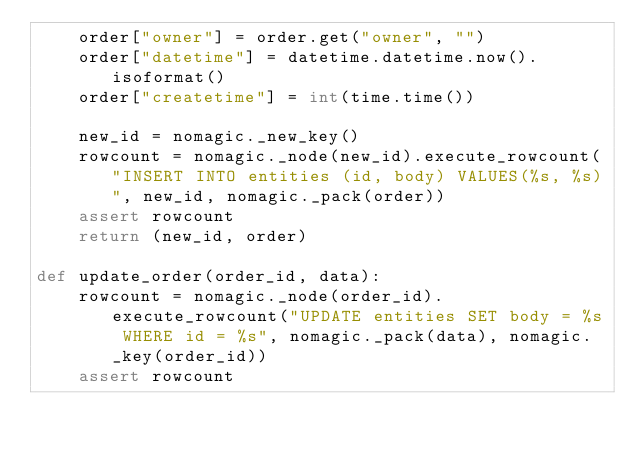<code> <loc_0><loc_0><loc_500><loc_500><_Python_>    order["owner"] = order.get("owner", "")
    order["datetime"] = datetime.datetime.now().isoformat()
    order["createtime"] = int(time.time())

    new_id = nomagic._new_key()
    rowcount = nomagic._node(new_id).execute_rowcount("INSERT INTO entities (id, body) VALUES(%s, %s)", new_id, nomagic._pack(order))
    assert rowcount
    return (new_id, order)

def update_order(order_id, data):
    rowcount = nomagic._node(order_id).execute_rowcount("UPDATE entities SET body = %s WHERE id = %s", nomagic._pack(data), nomagic._key(order_id))
    assert rowcount

</code> 